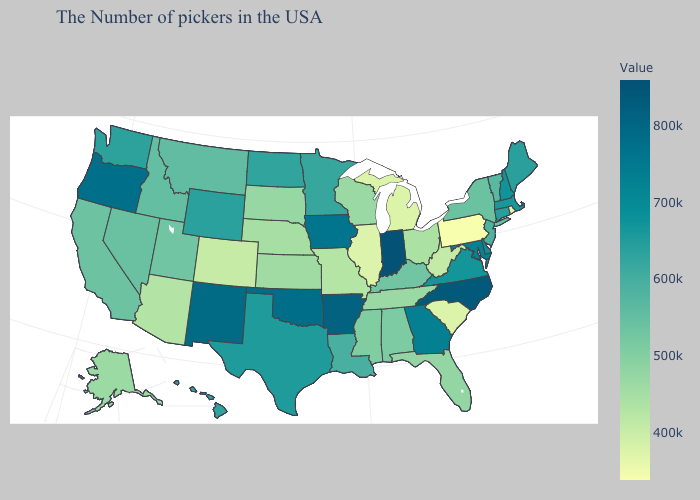Which states have the highest value in the USA?
Be succinct. Indiana. Which states have the lowest value in the South?
Write a very short answer. South Carolina. Which states have the lowest value in the MidWest?
Short answer required. Michigan. Which states have the highest value in the USA?
Give a very brief answer. Indiana. Which states hav the highest value in the Northeast?
Quick response, please. New Hampshire. Does Pennsylvania have the lowest value in the Northeast?
Short answer required. Yes. 